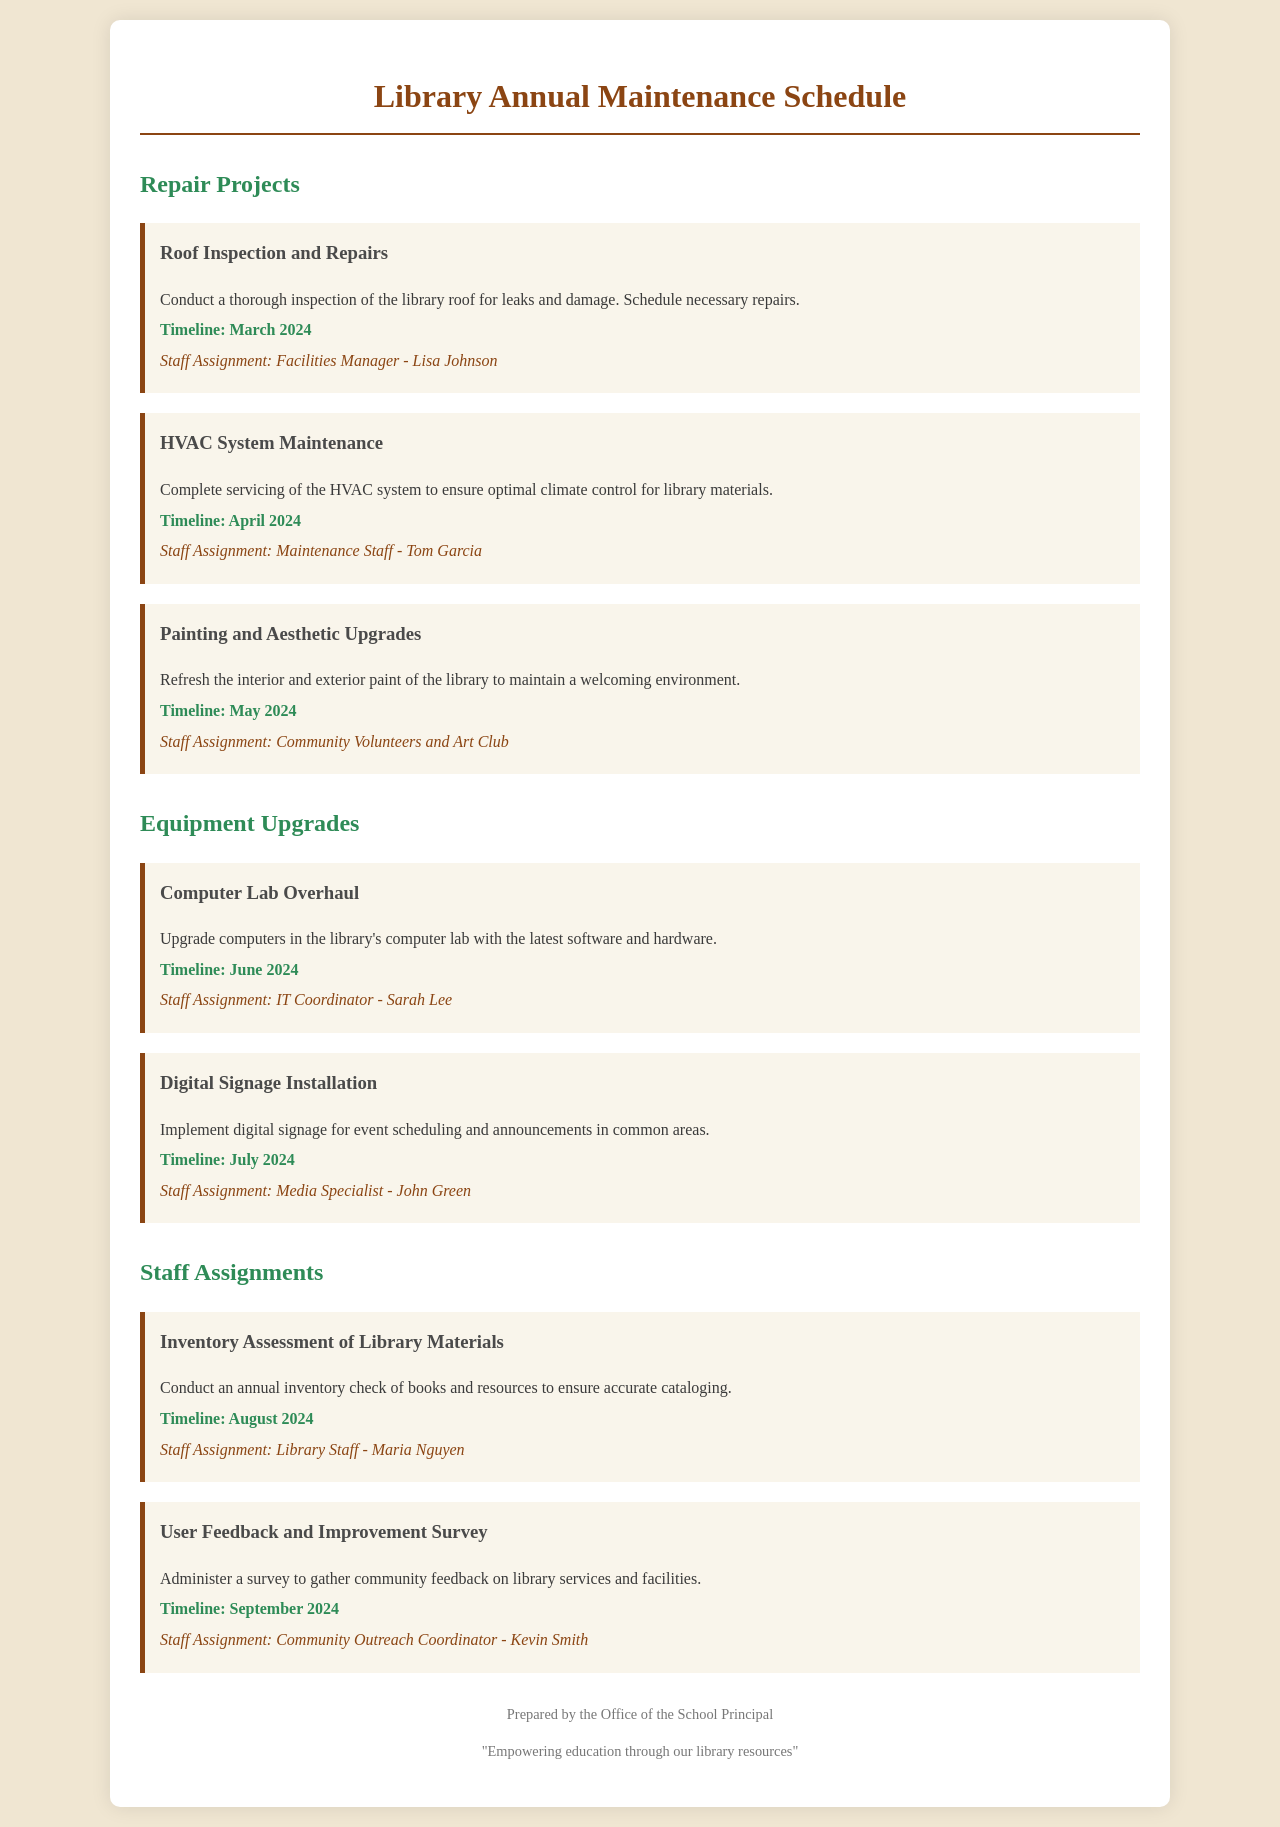What is the timeline for the roof inspection and repairs? The timeline for the roof inspection and repairs is mentioned in the document under Repair Projects.
Answer: March 2024 Who is assigned to the HVAC system maintenance? The staff assignment for the HVAC system maintenance is specified in the Repair Projects section of the document.
Answer: Maintenance Staff - Tom Garcia What type of upgrades are planned for June 2024? The upgrades planned for June 2024 are listed in the Equipment Upgrades section of the document.
Answer: Computer Lab Overhaul Which project involves community volunteers? The project that involves community volunteers is detailed in the Repair Projects section of the document.
Answer: Painting and Aesthetic Upgrades What will be conducted in August 2024? The scheduled activity for August 2024 is mentioned in the Staff Assignments section.
Answer: Inventory Assessment of Library Materials What is the purpose of the user feedback and improvement survey? The purpose of the survey is outlined in the Staff Assignments section.
Answer: Gather community feedback How many repair projects are listed in the document? A count of the repair projects listed in the document gives an idea of the total number.
Answer: Three Who is responsible for digital signage installation? The staff assignment for digital signage installation is provided under Equipment Upgrades.
Answer: Media Specialist - John Green 